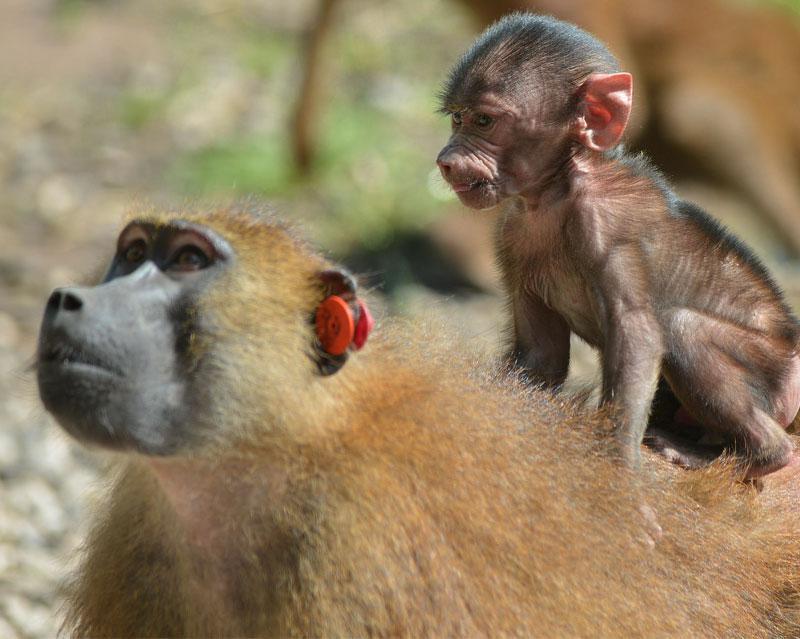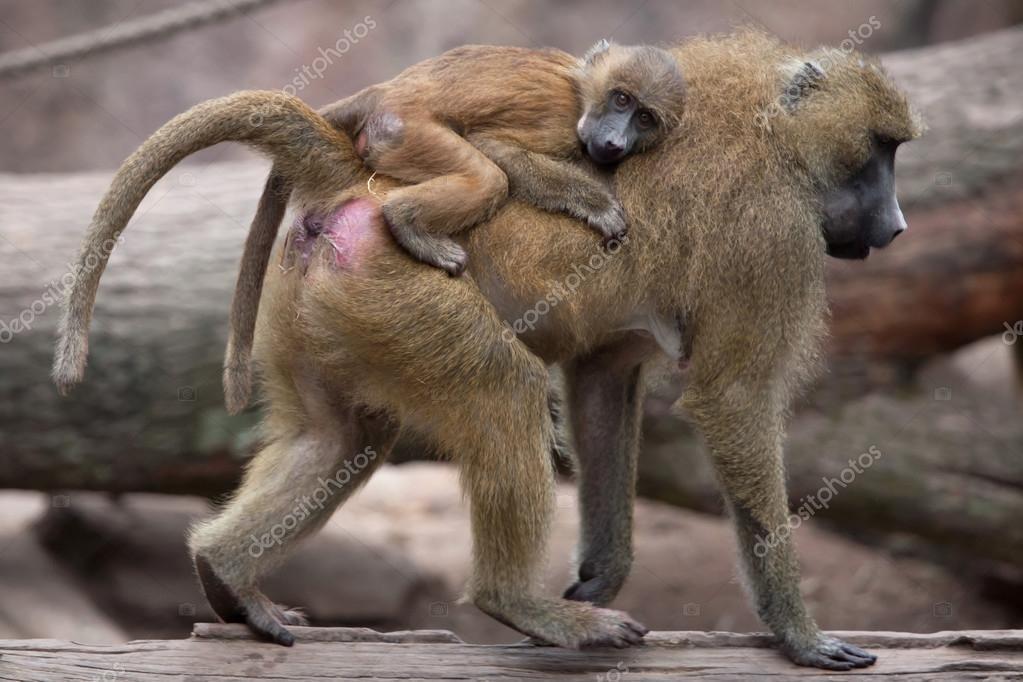The first image is the image on the left, the second image is the image on the right. For the images shown, is this caption "The right image contains no more than one baboon." true? Answer yes or no. No. The first image is the image on the left, the second image is the image on the right. Considering the images on both sides, is "An image shows a baby baboon clinging, with its body pressed flat, to the back of an adult baboon walking on all fours." valid? Answer yes or no. Yes. 